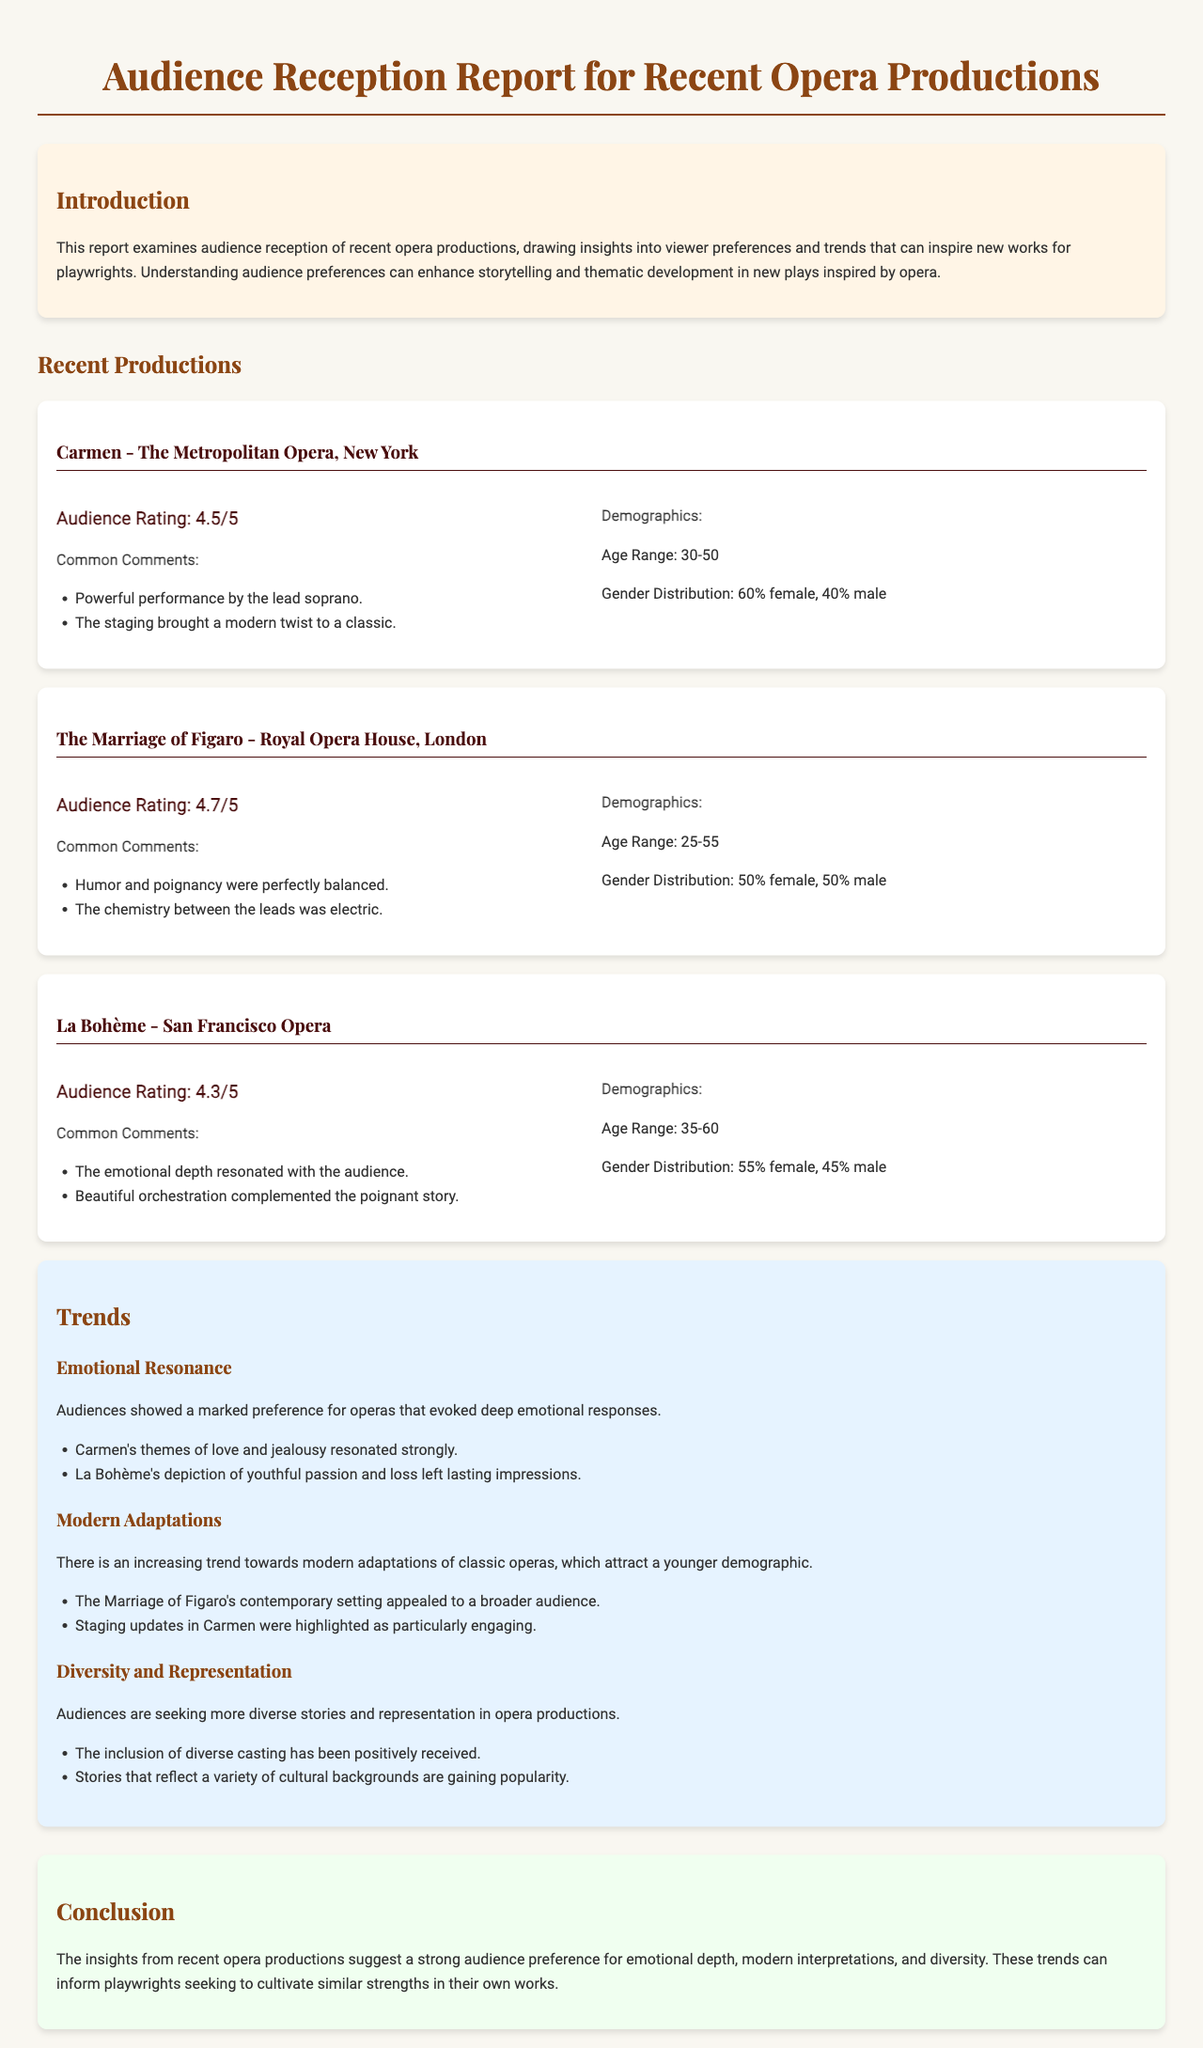What is the audience rating for Carmen? The audience rating for Carmen is presented in the feedback section of the production, showing a rating of 4.5 out of 5.
Answer: 4.5/5 What demographic made up the audience for La Bohème? The demographic information for La Bohème includes the age range and gender distribution of the attendees. The age range is 35-60 and the gender distribution is 55% female and 45% male.
Answer: Age Range: 35-60 What was a common comment about The Marriage of Figaro? The common comments about The Marriage of Figaro highlight positive aspects noted by the audience, such as humor and the chemistry between leads.
Answer: Humor and poignancy were perfectly balanced Which production had the highest audience rating? By comparing the audience ratings, we see that The Marriage of Figaro holds the highest rating at 4.7 out of 5.
Answer: 4.7/5 What theme resonated strongly in Carmen? An analysis of the audience feedback suggests that themes of love and jealousy resonated strongly with audiences, indicating emotional engagement.
Answer: Love and jealousy What trend is noted regarding modern adaptations? The report discusses an increasing trend towards modern adaptations of classic operas, which are attracting a younger demographic.
Answer: Modern adaptations What is one insight mentioned in the conclusion? The conclusion summarizes insights gained from audience reception, including strong preferences for emotional depth among viewers.
Answer: Emotional depth 